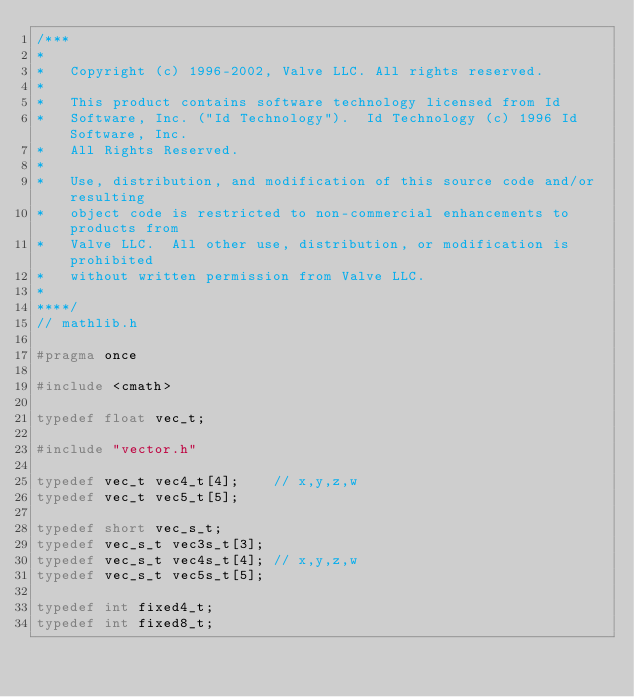Convert code to text. <code><loc_0><loc_0><loc_500><loc_500><_C_>/***
*
*	Copyright (c) 1996-2002, Valve LLC. All rights reserved.
*
*	This product contains software technology licensed from Id
*	Software, Inc. ("Id Technology").  Id Technology (c) 1996 Id Software, Inc.
*	All Rights Reserved.
*
*   Use, distribution, and modification of this source code and/or resulting
*   object code is restricted to non-commercial enhancements to products from
*   Valve LLC.  All other use, distribution, or modification is prohibited
*   without written permission from Valve LLC.
*
****/
// mathlib.h

#pragma once

#include <cmath>

typedef float vec_t;

#include "vector.h"

typedef vec_t vec4_t[4];	// x,y,z,w
typedef vec_t vec5_t[5];

typedef short vec_s_t;
typedef vec_s_t vec3s_t[3];
typedef vec_s_t vec4s_t[4];	// x,y,z,w
typedef vec_s_t vec5s_t[5];

typedef	int	fixed4_t;
typedef	int	fixed8_t;</code> 